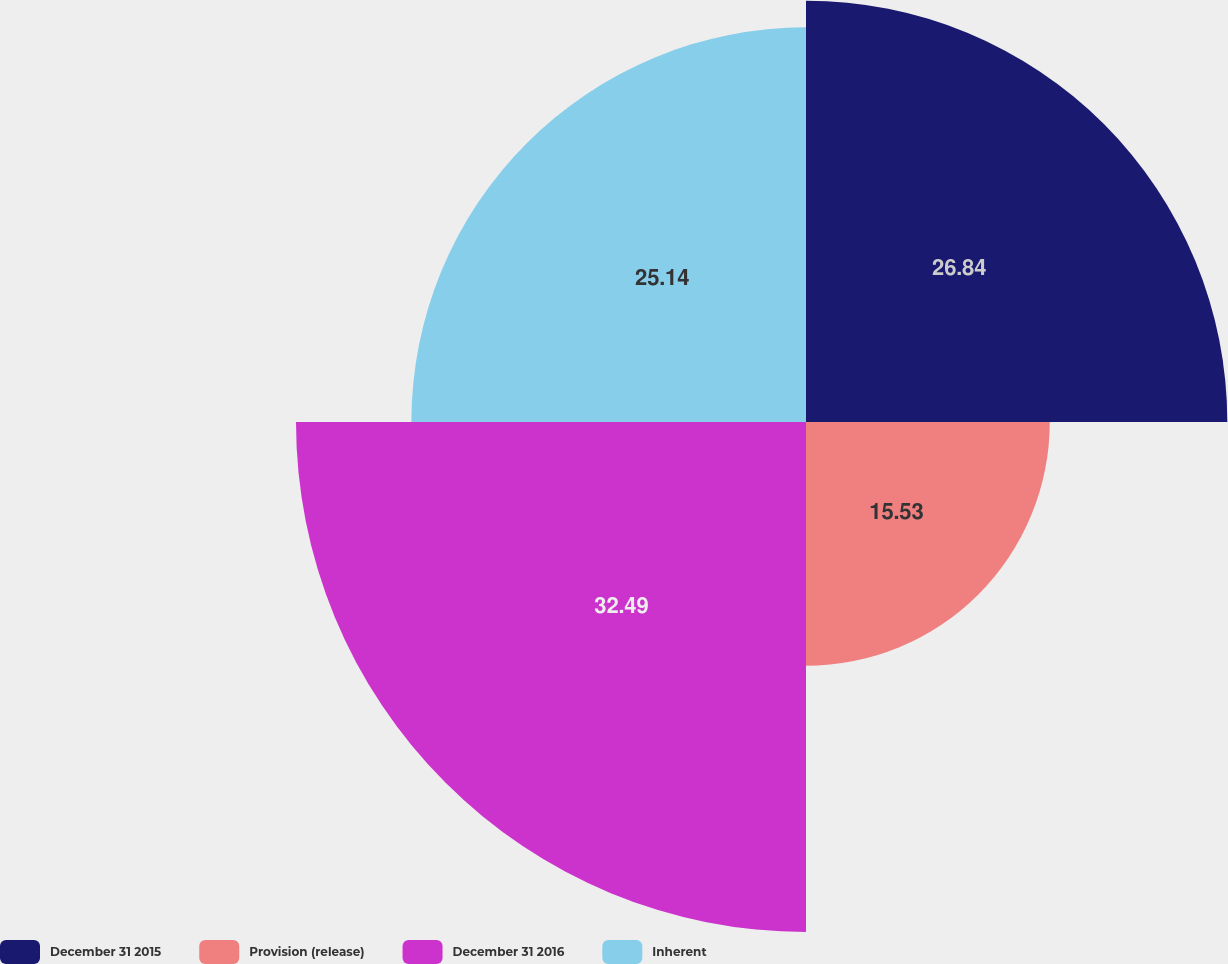Convert chart to OTSL. <chart><loc_0><loc_0><loc_500><loc_500><pie_chart><fcel>December 31 2015<fcel>Provision (release)<fcel>December 31 2016<fcel>Inherent<nl><fcel>26.84%<fcel>15.53%<fcel>32.49%<fcel>25.14%<nl></chart> 